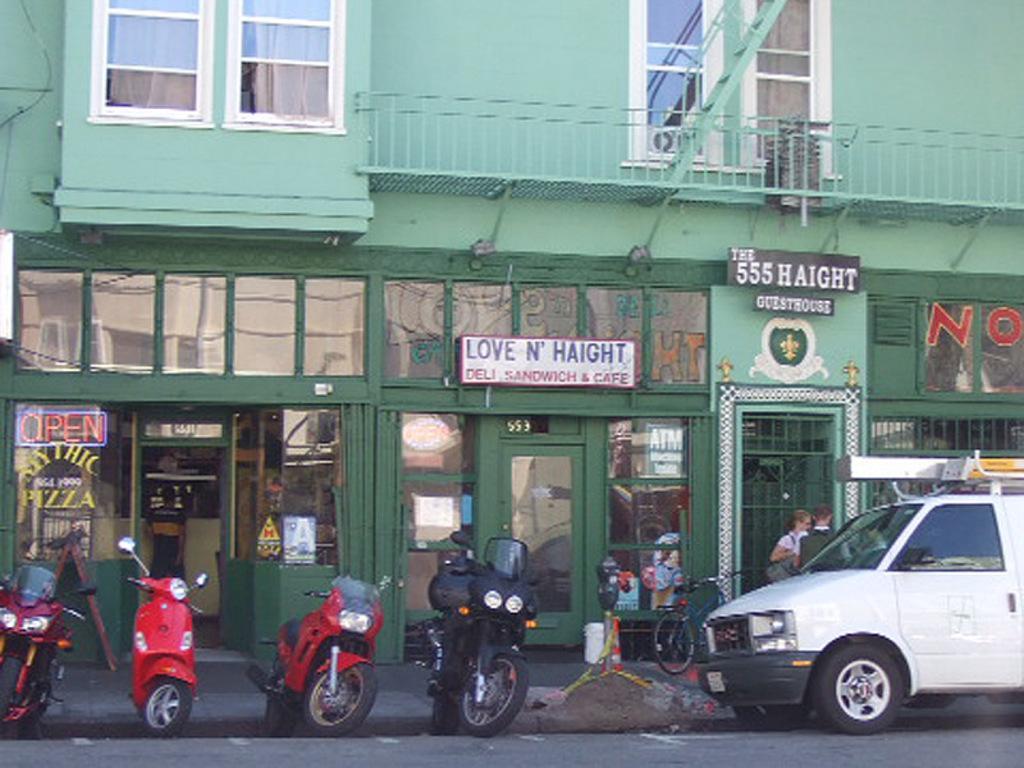Describe this image in one or two sentences. In this image, we can see a building and there are windows and we can see boards and doors and there are railings and some posters. At the bottom, there are vehicles on the road and we can see a traffic cone and ribbons and some other objects. 